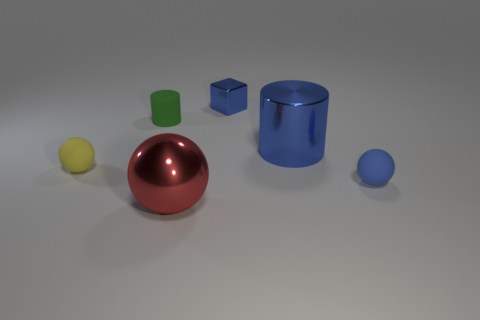How do the shapes in the image compare in terms of their geometry? The image presents a variety of geometric shapes. There's a sphere, a cylinder, and cubes. The sphere lacks any edges or vertices, presenting a completely smooth surface. The cylinder has a circular base and maintains the same width from bottom to top, having curved surfaces and flat circular ends. The cubes have equal-length edges, flat surfaces, and sharp corners. They exemplify a regular solid with faces that are identical squares. 